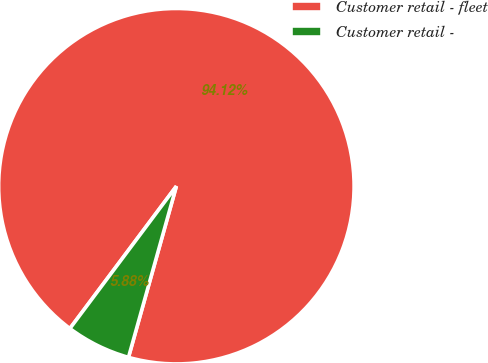<chart> <loc_0><loc_0><loc_500><loc_500><pie_chart><fcel>Customer retail - fleet<fcel>Customer retail -<nl><fcel>94.12%<fcel>5.88%<nl></chart> 